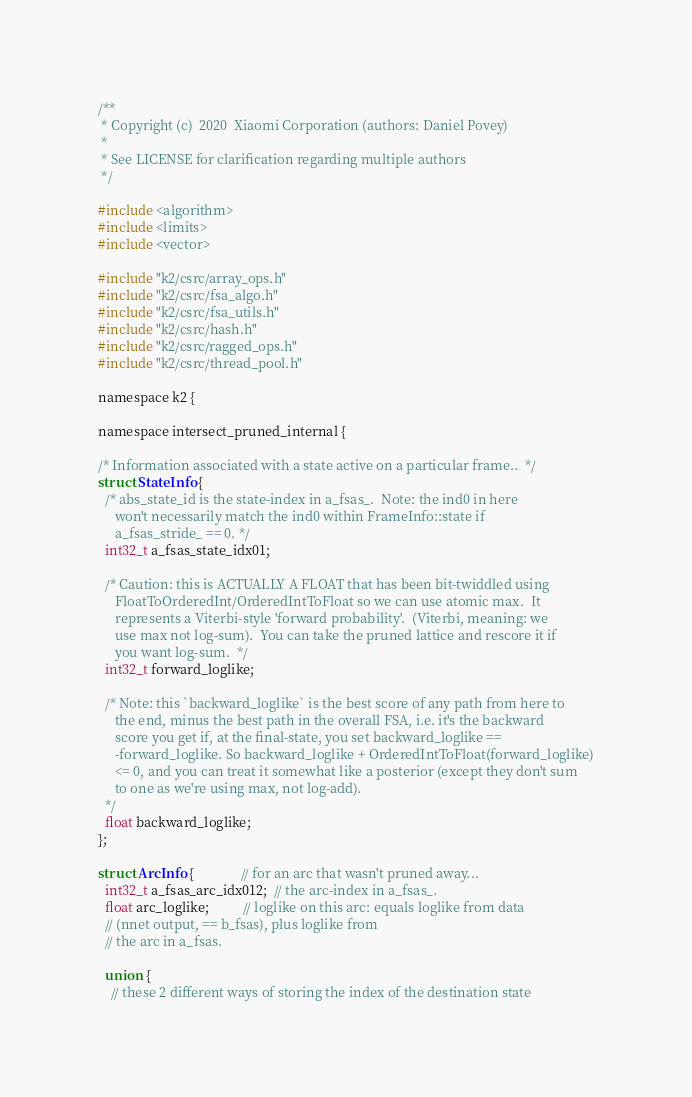<code> <loc_0><loc_0><loc_500><loc_500><_Cuda_>/**
 * Copyright (c)  2020  Xiaomi Corporation (authors: Daniel Povey)
 *
 * See LICENSE for clarification regarding multiple authors
 */

#include <algorithm>
#include <limits>
#include <vector>

#include "k2/csrc/array_ops.h"
#include "k2/csrc/fsa_algo.h"
#include "k2/csrc/fsa_utils.h"
#include "k2/csrc/hash.h"
#include "k2/csrc/ragged_ops.h"
#include "k2/csrc/thread_pool.h"

namespace k2 {

namespace intersect_pruned_internal {

/* Information associated with a state active on a particular frame..  */
struct StateInfo {
  /* abs_state_id is the state-index in a_fsas_.  Note: the ind0 in here
     won't necessarily match the ind0 within FrameInfo::state if
     a_fsas_stride_ == 0. */
  int32_t a_fsas_state_idx01;

  /* Caution: this is ACTUALLY A FLOAT that has been bit-twiddled using
     FloatToOrderedInt/OrderedIntToFloat so we can use atomic max.  It
     represents a Viterbi-style 'forward probability'.  (Viterbi, meaning: we
     use max not log-sum).  You can take the pruned lattice and rescore it if
     you want log-sum.  */
  int32_t forward_loglike;

  /* Note: this `backward_loglike` is the best score of any path from here to
     the end, minus the best path in the overall FSA, i.e. it's the backward
     score you get if, at the final-state, you set backward_loglike ==
     -forward_loglike. So backward_loglike + OrderedIntToFloat(forward_loglike)
     <= 0, and you can treat it somewhat like a posterior (except they don't sum
     to one as we're using max, not log-add).
  */
  float backward_loglike;
};

struct ArcInfo {              // for an arc that wasn't pruned away...
  int32_t a_fsas_arc_idx012;  // the arc-index in a_fsas_.
  float arc_loglike;          // loglike on this arc: equals loglike from data
  // (nnet output, == b_fsas), plus loglike from
  // the arc in a_fsas.

  union {
    // these 2 different ways of storing the index of the destination state</code> 